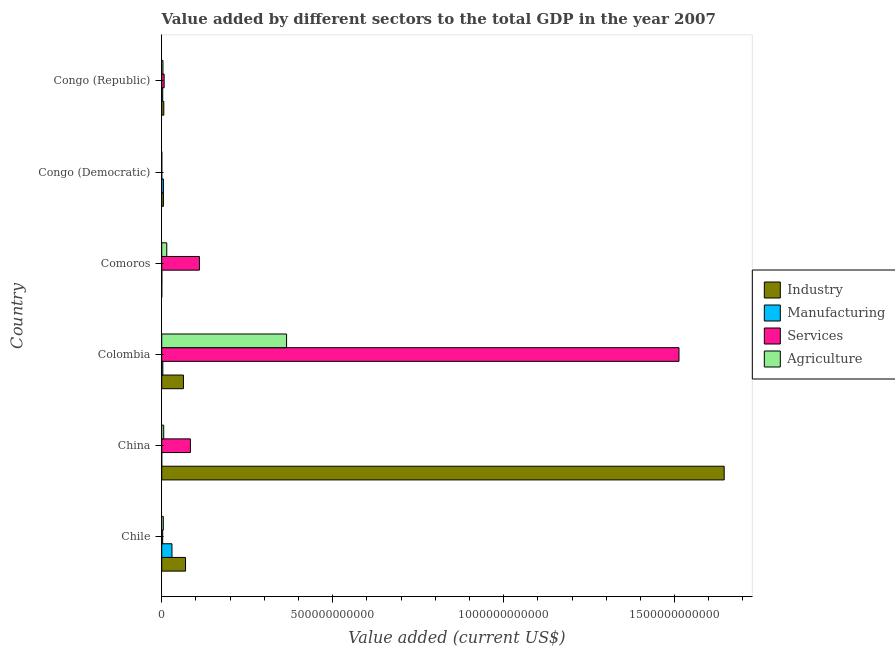Are the number of bars on each tick of the Y-axis equal?
Offer a very short reply. Yes. How many bars are there on the 6th tick from the top?
Offer a very short reply. 4. What is the label of the 4th group of bars from the top?
Your answer should be very brief. Colombia. In how many cases, is the number of bars for a given country not equal to the number of legend labels?
Offer a terse response. 0. What is the value added by services sector in Congo (Republic)?
Make the answer very short. 7.15e+09. Across all countries, what is the maximum value added by services sector?
Your answer should be compact. 1.51e+12. Across all countries, what is the minimum value added by agricultural sector?
Your answer should be compact. 1.89e+08. In which country was the value added by services sector minimum?
Your answer should be very brief. Congo (Democratic). What is the total value added by manufacturing sector in the graph?
Your answer should be compact. 4.16e+1. What is the difference between the value added by agricultural sector in Colombia and that in Congo (Republic)?
Make the answer very short. 3.62e+11. What is the difference between the value added by agricultural sector in Congo (Republic) and the value added by manufacturing sector in Chile?
Give a very brief answer. -2.64e+1. What is the average value added by industrial sector per country?
Offer a very short reply. 2.98e+11. What is the difference between the value added by services sector and value added by agricultural sector in Chile?
Offer a very short reply. -1.85e+09. In how many countries, is the value added by industrial sector greater than 700000000000 US$?
Offer a terse response. 1. What is the ratio of the value added by industrial sector in Chile to that in Congo (Democratic)?
Your answer should be very brief. 13.78. Is the value added by manufacturing sector in Comoros less than that in Congo (Democratic)?
Make the answer very short. Yes. What is the difference between the highest and the second highest value added by industrial sector?
Offer a very short reply. 1.58e+12. What is the difference between the highest and the lowest value added by agricultural sector?
Make the answer very short. 3.65e+11. In how many countries, is the value added by manufacturing sector greater than the average value added by manufacturing sector taken over all countries?
Give a very brief answer. 1. Is it the case that in every country, the sum of the value added by manufacturing sector and value added by agricultural sector is greater than the sum of value added by industrial sector and value added by services sector?
Your response must be concise. No. What does the 4th bar from the top in Congo (Democratic) represents?
Your answer should be very brief. Industry. What does the 3rd bar from the bottom in China represents?
Provide a succinct answer. Services. How many countries are there in the graph?
Provide a succinct answer. 6. What is the difference between two consecutive major ticks on the X-axis?
Your response must be concise. 5.00e+11. Where does the legend appear in the graph?
Offer a terse response. Center right. How are the legend labels stacked?
Keep it short and to the point. Vertical. What is the title of the graph?
Provide a succinct answer. Value added by different sectors to the total GDP in the year 2007. What is the label or title of the X-axis?
Make the answer very short. Value added (current US$). What is the label or title of the Y-axis?
Offer a terse response. Country. What is the Value added (current US$) in Industry in Chile?
Make the answer very short. 6.97e+1. What is the Value added (current US$) in Manufacturing in Chile?
Ensure brevity in your answer.  3.00e+1. What is the Value added (current US$) of Services in Chile?
Keep it short and to the point. 2.87e+09. What is the Value added (current US$) of Agriculture in Chile?
Provide a short and direct response. 4.72e+09. What is the Value added (current US$) of Industry in China?
Provide a succinct answer. 1.65e+12. What is the Value added (current US$) of Manufacturing in China?
Offer a terse response. 1.89e+07. What is the Value added (current US$) in Services in China?
Give a very brief answer. 8.39e+1. What is the Value added (current US$) in Agriculture in China?
Provide a succinct answer. 5.89e+09. What is the Value added (current US$) in Industry in Colombia?
Your response must be concise. 6.35e+1. What is the Value added (current US$) in Manufacturing in Colombia?
Provide a short and direct response. 3.28e+09. What is the Value added (current US$) in Services in Colombia?
Keep it short and to the point. 1.51e+12. What is the Value added (current US$) of Agriculture in Colombia?
Provide a short and direct response. 3.65e+11. What is the Value added (current US$) in Industry in Comoros?
Make the answer very short. 5.03e+07. What is the Value added (current US$) in Manufacturing in Comoros?
Your answer should be compact. 3.38e+08. What is the Value added (current US$) of Services in Comoros?
Offer a terse response. 1.10e+11. What is the Value added (current US$) in Agriculture in Comoros?
Provide a succinct answer. 1.48e+1. What is the Value added (current US$) of Industry in Congo (Democratic)?
Ensure brevity in your answer.  5.06e+09. What is the Value added (current US$) of Manufacturing in Congo (Democratic)?
Your response must be concise. 5.03e+09. What is the Value added (current US$) of Services in Congo (Democratic)?
Your answer should be compact. 2.23e+08. What is the Value added (current US$) in Agriculture in Congo (Democratic)?
Your answer should be very brief. 1.89e+08. What is the Value added (current US$) of Industry in Congo (Republic)?
Offer a very short reply. 6.15e+09. What is the Value added (current US$) of Manufacturing in Congo (Republic)?
Offer a terse response. 2.96e+09. What is the Value added (current US$) in Services in Congo (Republic)?
Offer a very short reply. 7.15e+09. What is the Value added (current US$) of Agriculture in Congo (Republic)?
Provide a succinct answer. 3.62e+09. Across all countries, what is the maximum Value added (current US$) in Industry?
Provide a short and direct response. 1.65e+12. Across all countries, what is the maximum Value added (current US$) in Manufacturing?
Ensure brevity in your answer.  3.00e+1. Across all countries, what is the maximum Value added (current US$) in Services?
Offer a terse response. 1.51e+12. Across all countries, what is the maximum Value added (current US$) of Agriculture?
Your response must be concise. 3.65e+11. Across all countries, what is the minimum Value added (current US$) in Industry?
Your answer should be compact. 5.03e+07. Across all countries, what is the minimum Value added (current US$) in Manufacturing?
Your answer should be compact. 1.89e+07. Across all countries, what is the minimum Value added (current US$) of Services?
Offer a terse response. 2.23e+08. Across all countries, what is the minimum Value added (current US$) in Agriculture?
Give a very brief answer. 1.89e+08. What is the total Value added (current US$) in Industry in the graph?
Make the answer very short. 1.79e+12. What is the total Value added (current US$) of Manufacturing in the graph?
Your answer should be very brief. 4.16e+1. What is the total Value added (current US$) in Services in the graph?
Offer a very short reply. 1.72e+12. What is the total Value added (current US$) of Agriculture in the graph?
Make the answer very short. 3.94e+11. What is the difference between the Value added (current US$) in Industry in Chile and that in China?
Keep it short and to the point. -1.58e+12. What is the difference between the Value added (current US$) in Manufacturing in Chile and that in China?
Provide a succinct answer. 3.00e+1. What is the difference between the Value added (current US$) in Services in Chile and that in China?
Offer a terse response. -8.10e+1. What is the difference between the Value added (current US$) of Agriculture in Chile and that in China?
Your response must be concise. -1.16e+09. What is the difference between the Value added (current US$) of Industry in Chile and that in Colombia?
Offer a very short reply. 6.13e+09. What is the difference between the Value added (current US$) in Manufacturing in Chile and that in Colombia?
Offer a very short reply. 2.67e+1. What is the difference between the Value added (current US$) in Services in Chile and that in Colombia?
Give a very brief answer. -1.51e+12. What is the difference between the Value added (current US$) in Agriculture in Chile and that in Colombia?
Your response must be concise. -3.60e+11. What is the difference between the Value added (current US$) of Industry in Chile and that in Comoros?
Your response must be concise. 6.96e+1. What is the difference between the Value added (current US$) in Manufacturing in Chile and that in Comoros?
Provide a succinct answer. 2.96e+1. What is the difference between the Value added (current US$) of Services in Chile and that in Comoros?
Your response must be concise. -1.07e+11. What is the difference between the Value added (current US$) of Agriculture in Chile and that in Comoros?
Keep it short and to the point. -1.00e+1. What is the difference between the Value added (current US$) in Industry in Chile and that in Congo (Democratic)?
Your answer should be compact. 6.46e+1. What is the difference between the Value added (current US$) in Manufacturing in Chile and that in Congo (Democratic)?
Keep it short and to the point. 2.50e+1. What is the difference between the Value added (current US$) of Services in Chile and that in Congo (Democratic)?
Make the answer very short. 2.65e+09. What is the difference between the Value added (current US$) of Agriculture in Chile and that in Congo (Democratic)?
Your answer should be compact. 4.53e+09. What is the difference between the Value added (current US$) in Industry in Chile and that in Congo (Republic)?
Provide a short and direct response. 6.35e+1. What is the difference between the Value added (current US$) of Manufacturing in Chile and that in Congo (Republic)?
Your answer should be very brief. 2.70e+1. What is the difference between the Value added (current US$) of Services in Chile and that in Congo (Republic)?
Your answer should be very brief. -4.28e+09. What is the difference between the Value added (current US$) of Agriculture in Chile and that in Congo (Republic)?
Provide a short and direct response. 1.11e+09. What is the difference between the Value added (current US$) in Industry in China and that in Colombia?
Give a very brief answer. 1.58e+12. What is the difference between the Value added (current US$) of Manufacturing in China and that in Colombia?
Offer a very short reply. -3.26e+09. What is the difference between the Value added (current US$) of Services in China and that in Colombia?
Make the answer very short. -1.43e+12. What is the difference between the Value added (current US$) of Agriculture in China and that in Colombia?
Your answer should be compact. -3.59e+11. What is the difference between the Value added (current US$) of Industry in China and that in Comoros?
Offer a very short reply. 1.64e+12. What is the difference between the Value added (current US$) of Manufacturing in China and that in Comoros?
Your answer should be compact. -3.20e+08. What is the difference between the Value added (current US$) of Services in China and that in Comoros?
Provide a succinct answer. -2.64e+1. What is the difference between the Value added (current US$) in Agriculture in China and that in Comoros?
Provide a succinct answer. -8.88e+09. What is the difference between the Value added (current US$) of Industry in China and that in Congo (Democratic)?
Offer a terse response. 1.64e+12. What is the difference between the Value added (current US$) in Manufacturing in China and that in Congo (Democratic)?
Your answer should be very brief. -5.01e+09. What is the difference between the Value added (current US$) in Services in China and that in Congo (Democratic)?
Ensure brevity in your answer.  8.37e+1. What is the difference between the Value added (current US$) of Agriculture in China and that in Congo (Democratic)?
Provide a short and direct response. 5.70e+09. What is the difference between the Value added (current US$) in Industry in China and that in Congo (Republic)?
Make the answer very short. 1.64e+12. What is the difference between the Value added (current US$) in Manufacturing in China and that in Congo (Republic)?
Ensure brevity in your answer.  -2.94e+09. What is the difference between the Value added (current US$) of Services in China and that in Congo (Republic)?
Your response must be concise. 7.67e+1. What is the difference between the Value added (current US$) of Agriculture in China and that in Congo (Republic)?
Offer a very short reply. 2.27e+09. What is the difference between the Value added (current US$) of Industry in Colombia and that in Comoros?
Give a very brief answer. 6.35e+1. What is the difference between the Value added (current US$) in Manufacturing in Colombia and that in Comoros?
Your answer should be very brief. 2.94e+09. What is the difference between the Value added (current US$) of Services in Colombia and that in Comoros?
Give a very brief answer. 1.40e+12. What is the difference between the Value added (current US$) of Agriculture in Colombia and that in Comoros?
Give a very brief answer. 3.50e+11. What is the difference between the Value added (current US$) in Industry in Colombia and that in Congo (Democratic)?
Provide a short and direct response. 5.85e+1. What is the difference between the Value added (current US$) in Manufacturing in Colombia and that in Congo (Democratic)?
Offer a terse response. -1.75e+09. What is the difference between the Value added (current US$) in Services in Colombia and that in Congo (Democratic)?
Provide a succinct answer. 1.51e+12. What is the difference between the Value added (current US$) in Agriculture in Colombia and that in Congo (Democratic)?
Provide a short and direct response. 3.65e+11. What is the difference between the Value added (current US$) of Industry in Colombia and that in Congo (Republic)?
Your response must be concise. 5.74e+1. What is the difference between the Value added (current US$) in Manufacturing in Colombia and that in Congo (Republic)?
Your answer should be compact. 3.16e+08. What is the difference between the Value added (current US$) of Services in Colombia and that in Congo (Republic)?
Provide a succinct answer. 1.51e+12. What is the difference between the Value added (current US$) in Agriculture in Colombia and that in Congo (Republic)?
Give a very brief answer. 3.62e+11. What is the difference between the Value added (current US$) in Industry in Comoros and that in Congo (Democratic)?
Offer a very short reply. -5.01e+09. What is the difference between the Value added (current US$) of Manufacturing in Comoros and that in Congo (Democratic)?
Your answer should be very brief. -4.69e+09. What is the difference between the Value added (current US$) in Services in Comoros and that in Congo (Democratic)?
Provide a succinct answer. 1.10e+11. What is the difference between the Value added (current US$) in Agriculture in Comoros and that in Congo (Democratic)?
Make the answer very short. 1.46e+1. What is the difference between the Value added (current US$) of Industry in Comoros and that in Congo (Republic)?
Your response must be concise. -6.10e+09. What is the difference between the Value added (current US$) in Manufacturing in Comoros and that in Congo (Republic)?
Provide a succinct answer. -2.62e+09. What is the difference between the Value added (current US$) of Services in Comoros and that in Congo (Republic)?
Provide a short and direct response. 1.03e+11. What is the difference between the Value added (current US$) of Agriculture in Comoros and that in Congo (Republic)?
Provide a succinct answer. 1.11e+1. What is the difference between the Value added (current US$) of Industry in Congo (Democratic) and that in Congo (Republic)?
Provide a short and direct response. -1.09e+09. What is the difference between the Value added (current US$) in Manufacturing in Congo (Democratic) and that in Congo (Republic)?
Provide a short and direct response. 2.07e+09. What is the difference between the Value added (current US$) in Services in Congo (Democratic) and that in Congo (Republic)?
Your answer should be very brief. -6.93e+09. What is the difference between the Value added (current US$) of Agriculture in Congo (Democratic) and that in Congo (Republic)?
Provide a short and direct response. -3.43e+09. What is the difference between the Value added (current US$) in Industry in Chile and the Value added (current US$) in Manufacturing in China?
Your answer should be compact. 6.96e+1. What is the difference between the Value added (current US$) in Industry in Chile and the Value added (current US$) in Services in China?
Ensure brevity in your answer.  -1.42e+1. What is the difference between the Value added (current US$) of Industry in Chile and the Value added (current US$) of Agriculture in China?
Keep it short and to the point. 6.38e+1. What is the difference between the Value added (current US$) of Manufacturing in Chile and the Value added (current US$) of Services in China?
Offer a very short reply. -5.39e+1. What is the difference between the Value added (current US$) in Manufacturing in Chile and the Value added (current US$) in Agriculture in China?
Ensure brevity in your answer.  2.41e+1. What is the difference between the Value added (current US$) of Services in Chile and the Value added (current US$) of Agriculture in China?
Make the answer very short. -3.02e+09. What is the difference between the Value added (current US$) in Industry in Chile and the Value added (current US$) in Manufacturing in Colombia?
Keep it short and to the point. 6.64e+1. What is the difference between the Value added (current US$) of Industry in Chile and the Value added (current US$) of Services in Colombia?
Your response must be concise. -1.44e+12. What is the difference between the Value added (current US$) of Industry in Chile and the Value added (current US$) of Agriculture in Colombia?
Your response must be concise. -2.96e+11. What is the difference between the Value added (current US$) of Manufacturing in Chile and the Value added (current US$) of Services in Colombia?
Your answer should be very brief. -1.48e+12. What is the difference between the Value added (current US$) of Manufacturing in Chile and the Value added (current US$) of Agriculture in Colombia?
Give a very brief answer. -3.35e+11. What is the difference between the Value added (current US$) of Services in Chile and the Value added (current US$) of Agriculture in Colombia?
Make the answer very short. -3.62e+11. What is the difference between the Value added (current US$) in Industry in Chile and the Value added (current US$) in Manufacturing in Comoros?
Keep it short and to the point. 6.93e+1. What is the difference between the Value added (current US$) in Industry in Chile and the Value added (current US$) in Services in Comoros?
Ensure brevity in your answer.  -4.06e+1. What is the difference between the Value added (current US$) in Industry in Chile and the Value added (current US$) in Agriculture in Comoros?
Your answer should be very brief. 5.49e+1. What is the difference between the Value added (current US$) of Manufacturing in Chile and the Value added (current US$) of Services in Comoros?
Make the answer very short. -8.03e+1. What is the difference between the Value added (current US$) in Manufacturing in Chile and the Value added (current US$) in Agriculture in Comoros?
Your response must be concise. 1.52e+1. What is the difference between the Value added (current US$) of Services in Chile and the Value added (current US$) of Agriculture in Comoros?
Your response must be concise. -1.19e+1. What is the difference between the Value added (current US$) of Industry in Chile and the Value added (current US$) of Manufacturing in Congo (Democratic)?
Make the answer very short. 6.46e+1. What is the difference between the Value added (current US$) in Industry in Chile and the Value added (current US$) in Services in Congo (Democratic)?
Provide a succinct answer. 6.94e+1. What is the difference between the Value added (current US$) of Industry in Chile and the Value added (current US$) of Agriculture in Congo (Democratic)?
Your answer should be compact. 6.95e+1. What is the difference between the Value added (current US$) of Manufacturing in Chile and the Value added (current US$) of Services in Congo (Democratic)?
Ensure brevity in your answer.  2.98e+1. What is the difference between the Value added (current US$) in Manufacturing in Chile and the Value added (current US$) in Agriculture in Congo (Democratic)?
Keep it short and to the point. 2.98e+1. What is the difference between the Value added (current US$) in Services in Chile and the Value added (current US$) in Agriculture in Congo (Democratic)?
Give a very brief answer. 2.68e+09. What is the difference between the Value added (current US$) of Industry in Chile and the Value added (current US$) of Manufacturing in Congo (Republic)?
Provide a short and direct response. 6.67e+1. What is the difference between the Value added (current US$) of Industry in Chile and the Value added (current US$) of Services in Congo (Republic)?
Your answer should be very brief. 6.25e+1. What is the difference between the Value added (current US$) of Industry in Chile and the Value added (current US$) of Agriculture in Congo (Republic)?
Ensure brevity in your answer.  6.61e+1. What is the difference between the Value added (current US$) of Manufacturing in Chile and the Value added (current US$) of Services in Congo (Republic)?
Provide a succinct answer. 2.28e+1. What is the difference between the Value added (current US$) of Manufacturing in Chile and the Value added (current US$) of Agriculture in Congo (Republic)?
Your response must be concise. 2.64e+1. What is the difference between the Value added (current US$) in Services in Chile and the Value added (current US$) in Agriculture in Congo (Republic)?
Keep it short and to the point. -7.43e+08. What is the difference between the Value added (current US$) in Industry in China and the Value added (current US$) in Manufacturing in Colombia?
Provide a short and direct response. 1.64e+12. What is the difference between the Value added (current US$) in Industry in China and the Value added (current US$) in Services in Colombia?
Give a very brief answer. 1.32e+11. What is the difference between the Value added (current US$) of Industry in China and the Value added (current US$) of Agriculture in Colombia?
Your answer should be compact. 1.28e+12. What is the difference between the Value added (current US$) in Manufacturing in China and the Value added (current US$) in Services in Colombia?
Offer a very short reply. -1.51e+12. What is the difference between the Value added (current US$) in Manufacturing in China and the Value added (current US$) in Agriculture in Colombia?
Your answer should be very brief. -3.65e+11. What is the difference between the Value added (current US$) in Services in China and the Value added (current US$) in Agriculture in Colombia?
Your answer should be very brief. -2.81e+11. What is the difference between the Value added (current US$) of Industry in China and the Value added (current US$) of Manufacturing in Comoros?
Offer a very short reply. 1.64e+12. What is the difference between the Value added (current US$) of Industry in China and the Value added (current US$) of Services in Comoros?
Offer a terse response. 1.53e+12. What is the difference between the Value added (current US$) of Industry in China and the Value added (current US$) of Agriculture in Comoros?
Provide a succinct answer. 1.63e+12. What is the difference between the Value added (current US$) in Manufacturing in China and the Value added (current US$) in Services in Comoros?
Your answer should be compact. -1.10e+11. What is the difference between the Value added (current US$) in Manufacturing in China and the Value added (current US$) in Agriculture in Comoros?
Ensure brevity in your answer.  -1.47e+1. What is the difference between the Value added (current US$) in Services in China and the Value added (current US$) in Agriculture in Comoros?
Offer a terse response. 6.91e+1. What is the difference between the Value added (current US$) in Industry in China and the Value added (current US$) in Manufacturing in Congo (Democratic)?
Your answer should be compact. 1.64e+12. What is the difference between the Value added (current US$) in Industry in China and the Value added (current US$) in Services in Congo (Democratic)?
Your answer should be very brief. 1.64e+12. What is the difference between the Value added (current US$) of Industry in China and the Value added (current US$) of Agriculture in Congo (Democratic)?
Your answer should be very brief. 1.64e+12. What is the difference between the Value added (current US$) of Manufacturing in China and the Value added (current US$) of Services in Congo (Democratic)?
Ensure brevity in your answer.  -2.04e+08. What is the difference between the Value added (current US$) in Manufacturing in China and the Value added (current US$) in Agriculture in Congo (Democratic)?
Offer a very short reply. -1.70e+08. What is the difference between the Value added (current US$) of Services in China and the Value added (current US$) of Agriculture in Congo (Democratic)?
Ensure brevity in your answer.  8.37e+1. What is the difference between the Value added (current US$) in Industry in China and the Value added (current US$) in Manufacturing in Congo (Republic)?
Offer a very short reply. 1.64e+12. What is the difference between the Value added (current US$) in Industry in China and the Value added (current US$) in Services in Congo (Republic)?
Offer a very short reply. 1.64e+12. What is the difference between the Value added (current US$) of Industry in China and the Value added (current US$) of Agriculture in Congo (Republic)?
Your answer should be compact. 1.64e+12. What is the difference between the Value added (current US$) of Manufacturing in China and the Value added (current US$) of Services in Congo (Republic)?
Your response must be concise. -7.14e+09. What is the difference between the Value added (current US$) in Manufacturing in China and the Value added (current US$) in Agriculture in Congo (Republic)?
Your answer should be very brief. -3.60e+09. What is the difference between the Value added (current US$) in Services in China and the Value added (current US$) in Agriculture in Congo (Republic)?
Ensure brevity in your answer.  8.03e+1. What is the difference between the Value added (current US$) of Industry in Colombia and the Value added (current US$) of Manufacturing in Comoros?
Your answer should be compact. 6.32e+1. What is the difference between the Value added (current US$) in Industry in Colombia and the Value added (current US$) in Services in Comoros?
Your answer should be compact. -4.67e+1. What is the difference between the Value added (current US$) of Industry in Colombia and the Value added (current US$) of Agriculture in Comoros?
Keep it short and to the point. 4.88e+1. What is the difference between the Value added (current US$) in Manufacturing in Colombia and the Value added (current US$) in Services in Comoros?
Your response must be concise. -1.07e+11. What is the difference between the Value added (current US$) in Manufacturing in Colombia and the Value added (current US$) in Agriculture in Comoros?
Your answer should be compact. -1.15e+1. What is the difference between the Value added (current US$) in Services in Colombia and the Value added (current US$) in Agriculture in Comoros?
Your answer should be very brief. 1.50e+12. What is the difference between the Value added (current US$) in Industry in Colombia and the Value added (current US$) in Manufacturing in Congo (Democratic)?
Keep it short and to the point. 5.85e+1. What is the difference between the Value added (current US$) of Industry in Colombia and the Value added (current US$) of Services in Congo (Democratic)?
Your answer should be very brief. 6.33e+1. What is the difference between the Value added (current US$) of Industry in Colombia and the Value added (current US$) of Agriculture in Congo (Democratic)?
Your response must be concise. 6.33e+1. What is the difference between the Value added (current US$) in Manufacturing in Colombia and the Value added (current US$) in Services in Congo (Democratic)?
Provide a short and direct response. 3.05e+09. What is the difference between the Value added (current US$) in Manufacturing in Colombia and the Value added (current US$) in Agriculture in Congo (Democratic)?
Provide a succinct answer. 3.09e+09. What is the difference between the Value added (current US$) in Services in Colombia and the Value added (current US$) in Agriculture in Congo (Democratic)?
Your answer should be very brief. 1.51e+12. What is the difference between the Value added (current US$) in Industry in Colombia and the Value added (current US$) in Manufacturing in Congo (Republic)?
Provide a short and direct response. 6.06e+1. What is the difference between the Value added (current US$) of Industry in Colombia and the Value added (current US$) of Services in Congo (Republic)?
Provide a succinct answer. 5.64e+1. What is the difference between the Value added (current US$) in Industry in Colombia and the Value added (current US$) in Agriculture in Congo (Republic)?
Give a very brief answer. 5.99e+1. What is the difference between the Value added (current US$) of Manufacturing in Colombia and the Value added (current US$) of Services in Congo (Republic)?
Offer a terse response. -3.88e+09. What is the difference between the Value added (current US$) in Manufacturing in Colombia and the Value added (current US$) in Agriculture in Congo (Republic)?
Your response must be concise. -3.38e+08. What is the difference between the Value added (current US$) in Services in Colombia and the Value added (current US$) in Agriculture in Congo (Republic)?
Keep it short and to the point. 1.51e+12. What is the difference between the Value added (current US$) in Industry in Comoros and the Value added (current US$) in Manufacturing in Congo (Democratic)?
Your answer should be very brief. -4.98e+09. What is the difference between the Value added (current US$) in Industry in Comoros and the Value added (current US$) in Services in Congo (Democratic)?
Your answer should be very brief. -1.73e+08. What is the difference between the Value added (current US$) of Industry in Comoros and the Value added (current US$) of Agriculture in Congo (Democratic)?
Offer a very short reply. -1.38e+08. What is the difference between the Value added (current US$) in Manufacturing in Comoros and the Value added (current US$) in Services in Congo (Democratic)?
Your response must be concise. 1.15e+08. What is the difference between the Value added (current US$) of Manufacturing in Comoros and the Value added (current US$) of Agriculture in Congo (Democratic)?
Keep it short and to the point. 1.50e+08. What is the difference between the Value added (current US$) in Services in Comoros and the Value added (current US$) in Agriculture in Congo (Democratic)?
Your answer should be very brief. 1.10e+11. What is the difference between the Value added (current US$) of Industry in Comoros and the Value added (current US$) of Manufacturing in Congo (Republic)?
Keep it short and to the point. -2.91e+09. What is the difference between the Value added (current US$) of Industry in Comoros and the Value added (current US$) of Services in Congo (Republic)?
Provide a short and direct response. -7.10e+09. What is the difference between the Value added (current US$) of Industry in Comoros and the Value added (current US$) of Agriculture in Congo (Republic)?
Your answer should be very brief. -3.57e+09. What is the difference between the Value added (current US$) of Manufacturing in Comoros and the Value added (current US$) of Services in Congo (Republic)?
Your response must be concise. -6.82e+09. What is the difference between the Value added (current US$) in Manufacturing in Comoros and the Value added (current US$) in Agriculture in Congo (Republic)?
Your response must be concise. -3.28e+09. What is the difference between the Value added (current US$) in Services in Comoros and the Value added (current US$) in Agriculture in Congo (Republic)?
Your answer should be compact. 1.07e+11. What is the difference between the Value added (current US$) of Industry in Congo (Democratic) and the Value added (current US$) of Manufacturing in Congo (Republic)?
Keep it short and to the point. 2.09e+09. What is the difference between the Value added (current US$) of Industry in Congo (Democratic) and the Value added (current US$) of Services in Congo (Republic)?
Make the answer very short. -2.10e+09. What is the difference between the Value added (current US$) of Industry in Congo (Democratic) and the Value added (current US$) of Agriculture in Congo (Republic)?
Provide a short and direct response. 1.44e+09. What is the difference between the Value added (current US$) in Manufacturing in Congo (Democratic) and the Value added (current US$) in Services in Congo (Republic)?
Offer a very short reply. -2.13e+09. What is the difference between the Value added (current US$) in Manufacturing in Congo (Democratic) and the Value added (current US$) in Agriculture in Congo (Republic)?
Offer a very short reply. 1.41e+09. What is the difference between the Value added (current US$) in Services in Congo (Democratic) and the Value added (current US$) in Agriculture in Congo (Republic)?
Provide a short and direct response. -3.39e+09. What is the average Value added (current US$) in Industry per country?
Make the answer very short. 2.98e+11. What is the average Value added (current US$) of Manufacturing per country?
Offer a very short reply. 6.93e+09. What is the average Value added (current US$) in Services per country?
Provide a succinct answer. 2.86e+11. What is the average Value added (current US$) of Agriculture per country?
Ensure brevity in your answer.  6.57e+1. What is the difference between the Value added (current US$) in Industry and Value added (current US$) in Manufacturing in Chile?
Your answer should be very brief. 3.97e+1. What is the difference between the Value added (current US$) of Industry and Value added (current US$) of Services in Chile?
Provide a succinct answer. 6.68e+1. What is the difference between the Value added (current US$) of Industry and Value added (current US$) of Agriculture in Chile?
Offer a very short reply. 6.49e+1. What is the difference between the Value added (current US$) in Manufacturing and Value added (current US$) in Services in Chile?
Offer a very short reply. 2.71e+1. What is the difference between the Value added (current US$) of Manufacturing and Value added (current US$) of Agriculture in Chile?
Give a very brief answer. 2.53e+1. What is the difference between the Value added (current US$) in Services and Value added (current US$) in Agriculture in Chile?
Offer a terse response. -1.85e+09. What is the difference between the Value added (current US$) of Industry and Value added (current US$) of Manufacturing in China?
Your answer should be compact. 1.65e+12. What is the difference between the Value added (current US$) of Industry and Value added (current US$) of Services in China?
Provide a short and direct response. 1.56e+12. What is the difference between the Value added (current US$) of Industry and Value added (current US$) of Agriculture in China?
Your response must be concise. 1.64e+12. What is the difference between the Value added (current US$) of Manufacturing and Value added (current US$) of Services in China?
Your answer should be very brief. -8.39e+1. What is the difference between the Value added (current US$) of Manufacturing and Value added (current US$) of Agriculture in China?
Your answer should be very brief. -5.87e+09. What is the difference between the Value added (current US$) of Services and Value added (current US$) of Agriculture in China?
Your response must be concise. 7.80e+1. What is the difference between the Value added (current US$) in Industry and Value added (current US$) in Manufacturing in Colombia?
Ensure brevity in your answer.  6.03e+1. What is the difference between the Value added (current US$) of Industry and Value added (current US$) of Services in Colombia?
Your answer should be compact. -1.45e+12. What is the difference between the Value added (current US$) in Industry and Value added (current US$) in Agriculture in Colombia?
Your answer should be very brief. -3.02e+11. What is the difference between the Value added (current US$) of Manufacturing and Value added (current US$) of Services in Colombia?
Your answer should be compact. -1.51e+12. What is the difference between the Value added (current US$) of Manufacturing and Value added (current US$) of Agriculture in Colombia?
Offer a very short reply. -3.62e+11. What is the difference between the Value added (current US$) of Services and Value added (current US$) of Agriculture in Colombia?
Your response must be concise. 1.15e+12. What is the difference between the Value added (current US$) in Industry and Value added (current US$) in Manufacturing in Comoros?
Offer a terse response. -2.88e+08. What is the difference between the Value added (current US$) of Industry and Value added (current US$) of Services in Comoros?
Give a very brief answer. -1.10e+11. What is the difference between the Value added (current US$) of Industry and Value added (current US$) of Agriculture in Comoros?
Ensure brevity in your answer.  -1.47e+1. What is the difference between the Value added (current US$) in Manufacturing and Value added (current US$) in Services in Comoros?
Make the answer very short. -1.10e+11. What is the difference between the Value added (current US$) in Manufacturing and Value added (current US$) in Agriculture in Comoros?
Your answer should be very brief. -1.44e+1. What is the difference between the Value added (current US$) in Services and Value added (current US$) in Agriculture in Comoros?
Your answer should be compact. 9.55e+1. What is the difference between the Value added (current US$) of Industry and Value added (current US$) of Manufacturing in Congo (Democratic)?
Give a very brief answer. 2.77e+07. What is the difference between the Value added (current US$) of Industry and Value added (current US$) of Services in Congo (Democratic)?
Provide a succinct answer. 4.83e+09. What is the difference between the Value added (current US$) of Industry and Value added (current US$) of Agriculture in Congo (Democratic)?
Your answer should be very brief. 4.87e+09. What is the difference between the Value added (current US$) of Manufacturing and Value added (current US$) of Services in Congo (Democratic)?
Make the answer very short. 4.80e+09. What is the difference between the Value added (current US$) in Manufacturing and Value added (current US$) in Agriculture in Congo (Democratic)?
Offer a very short reply. 4.84e+09. What is the difference between the Value added (current US$) in Services and Value added (current US$) in Agriculture in Congo (Democratic)?
Make the answer very short. 3.45e+07. What is the difference between the Value added (current US$) of Industry and Value added (current US$) of Manufacturing in Congo (Republic)?
Give a very brief answer. 3.19e+09. What is the difference between the Value added (current US$) in Industry and Value added (current US$) in Services in Congo (Republic)?
Your answer should be very brief. -1.01e+09. What is the difference between the Value added (current US$) of Industry and Value added (current US$) of Agriculture in Congo (Republic)?
Make the answer very short. 2.53e+09. What is the difference between the Value added (current US$) in Manufacturing and Value added (current US$) in Services in Congo (Republic)?
Your answer should be compact. -4.19e+09. What is the difference between the Value added (current US$) in Manufacturing and Value added (current US$) in Agriculture in Congo (Republic)?
Your response must be concise. -6.54e+08. What is the difference between the Value added (current US$) in Services and Value added (current US$) in Agriculture in Congo (Republic)?
Your answer should be compact. 3.54e+09. What is the ratio of the Value added (current US$) in Industry in Chile to that in China?
Offer a very short reply. 0.04. What is the ratio of the Value added (current US$) in Manufacturing in Chile to that in China?
Give a very brief answer. 1589.7. What is the ratio of the Value added (current US$) in Services in Chile to that in China?
Your answer should be compact. 0.03. What is the ratio of the Value added (current US$) of Agriculture in Chile to that in China?
Offer a very short reply. 0.8. What is the ratio of the Value added (current US$) of Industry in Chile to that in Colombia?
Offer a terse response. 1.1. What is the ratio of the Value added (current US$) of Manufacturing in Chile to that in Colombia?
Make the answer very short. 9.15. What is the ratio of the Value added (current US$) of Services in Chile to that in Colombia?
Ensure brevity in your answer.  0. What is the ratio of the Value added (current US$) in Agriculture in Chile to that in Colombia?
Your response must be concise. 0.01. What is the ratio of the Value added (current US$) in Industry in Chile to that in Comoros?
Offer a terse response. 1383.95. What is the ratio of the Value added (current US$) in Manufacturing in Chile to that in Comoros?
Provide a short and direct response. 88.6. What is the ratio of the Value added (current US$) in Services in Chile to that in Comoros?
Make the answer very short. 0.03. What is the ratio of the Value added (current US$) in Agriculture in Chile to that in Comoros?
Provide a succinct answer. 0.32. What is the ratio of the Value added (current US$) of Industry in Chile to that in Congo (Democratic)?
Ensure brevity in your answer.  13.78. What is the ratio of the Value added (current US$) of Manufacturing in Chile to that in Congo (Democratic)?
Your answer should be very brief. 5.96. What is the ratio of the Value added (current US$) of Services in Chile to that in Congo (Democratic)?
Give a very brief answer. 12.86. What is the ratio of the Value added (current US$) of Agriculture in Chile to that in Congo (Democratic)?
Offer a very short reply. 25.01. What is the ratio of the Value added (current US$) in Industry in Chile to that in Congo (Republic)?
Your answer should be compact. 11.33. What is the ratio of the Value added (current US$) in Manufacturing in Chile to that in Congo (Republic)?
Provide a succinct answer. 10.12. What is the ratio of the Value added (current US$) of Services in Chile to that in Congo (Republic)?
Give a very brief answer. 0.4. What is the ratio of the Value added (current US$) of Agriculture in Chile to that in Congo (Republic)?
Offer a very short reply. 1.31. What is the ratio of the Value added (current US$) in Industry in China to that in Colombia?
Your response must be concise. 25.89. What is the ratio of the Value added (current US$) in Manufacturing in China to that in Colombia?
Give a very brief answer. 0.01. What is the ratio of the Value added (current US$) in Services in China to that in Colombia?
Keep it short and to the point. 0.06. What is the ratio of the Value added (current US$) in Agriculture in China to that in Colombia?
Offer a very short reply. 0.02. What is the ratio of the Value added (current US$) of Industry in China to that in Comoros?
Provide a succinct answer. 3.27e+04. What is the ratio of the Value added (current US$) in Manufacturing in China to that in Comoros?
Make the answer very short. 0.06. What is the ratio of the Value added (current US$) of Services in China to that in Comoros?
Your answer should be compact. 0.76. What is the ratio of the Value added (current US$) in Agriculture in China to that in Comoros?
Make the answer very short. 0.4. What is the ratio of the Value added (current US$) of Industry in China to that in Congo (Democratic)?
Your answer should be compact. 325.39. What is the ratio of the Value added (current US$) in Manufacturing in China to that in Congo (Democratic)?
Give a very brief answer. 0. What is the ratio of the Value added (current US$) in Services in China to that in Congo (Democratic)?
Your answer should be very brief. 375.69. What is the ratio of the Value added (current US$) in Agriculture in China to that in Congo (Democratic)?
Make the answer very short. 31.18. What is the ratio of the Value added (current US$) in Industry in China to that in Congo (Republic)?
Keep it short and to the point. 267.56. What is the ratio of the Value added (current US$) in Manufacturing in China to that in Congo (Republic)?
Provide a short and direct response. 0.01. What is the ratio of the Value added (current US$) of Services in China to that in Congo (Republic)?
Provide a succinct answer. 11.72. What is the ratio of the Value added (current US$) of Agriculture in China to that in Congo (Republic)?
Your answer should be compact. 1.63. What is the ratio of the Value added (current US$) of Industry in Colombia to that in Comoros?
Your response must be concise. 1262.12. What is the ratio of the Value added (current US$) in Manufacturing in Colombia to that in Comoros?
Ensure brevity in your answer.  9.69. What is the ratio of the Value added (current US$) of Services in Colombia to that in Comoros?
Ensure brevity in your answer.  13.72. What is the ratio of the Value added (current US$) of Agriculture in Colombia to that in Comoros?
Offer a very short reply. 24.73. What is the ratio of the Value added (current US$) in Industry in Colombia to that in Congo (Democratic)?
Your response must be concise. 12.57. What is the ratio of the Value added (current US$) of Manufacturing in Colombia to that in Congo (Democratic)?
Your response must be concise. 0.65. What is the ratio of the Value added (current US$) in Services in Colombia to that in Congo (Democratic)?
Offer a very short reply. 6775.45. What is the ratio of the Value added (current US$) in Agriculture in Colombia to that in Congo (Democratic)?
Make the answer very short. 1934.07. What is the ratio of the Value added (current US$) in Industry in Colombia to that in Congo (Republic)?
Provide a succinct answer. 10.33. What is the ratio of the Value added (current US$) of Manufacturing in Colombia to that in Congo (Republic)?
Ensure brevity in your answer.  1.11. What is the ratio of the Value added (current US$) of Services in Colombia to that in Congo (Republic)?
Keep it short and to the point. 211.44. What is the ratio of the Value added (current US$) in Agriculture in Colombia to that in Congo (Republic)?
Your answer should be compact. 101.01. What is the ratio of the Value added (current US$) in Manufacturing in Comoros to that in Congo (Democratic)?
Make the answer very short. 0.07. What is the ratio of the Value added (current US$) of Services in Comoros to that in Congo (Democratic)?
Ensure brevity in your answer.  493.86. What is the ratio of the Value added (current US$) of Agriculture in Comoros to that in Congo (Democratic)?
Provide a short and direct response. 78.19. What is the ratio of the Value added (current US$) in Industry in Comoros to that in Congo (Republic)?
Ensure brevity in your answer.  0.01. What is the ratio of the Value added (current US$) in Manufacturing in Comoros to that in Congo (Republic)?
Provide a short and direct response. 0.11. What is the ratio of the Value added (current US$) of Services in Comoros to that in Congo (Republic)?
Give a very brief answer. 15.41. What is the ratio of the Value added (current US$) of Agriculture in Comoros to that in Congo (Republic)?
Offer a terse response. 4.08. What is the ratio of the Value added (current US$) in Industry in Congo (Democratic) to that in Congo (Republic)?
Your response must be concise. 0.82. What is the ratio of the Value added (current US$) of Manufacturing in Congo (Democratic) to that in Congo (Republic)?
Your answer should be compact. 1.7. What is the ratio of the Value added (current US$) in Services in Congo (Democratic) to that in Congo (Republic)?
Offer a terse response. 0.03. What is the ratio of the Value added (current US$) of Agriculture in Congo (Democratic) to that in Congo (Republic)?
Give a very brief answer. 0.05. What is the difference between the highest and the second highest Value added (current US$) of Industry?
Offer a very short reply. 1.58e+12. What is the difference between the highest and the second highest Value added (current US$) of Manufacturing?
Keep it short and to the point. 2.50e+1. What is the difference between the highest and the second highest Value added (current US$) of Services?
Keep it short and to the point. 1.40e+12. What is the difference between the highest and the second highest Value added (current US$) in Agriculture?
Make the answer very short. 3.50e+11. What is the difference between the highest and the lowest Value added (current US$) in Industry?
Provide a short and direct response. 1.64e+12. What is the difference between the highest and the lowest Value added (current US$) of Manufacturing?
Offer a very short reply. 3.00e+1. What is the difference between the highest and the lowest Value added (current US$) of Services?
Offer a terse response. 1.51e+12. What is the difference between the highest and the lowest Value added (current US$) of Agriculture?
Your response must be concise. 3.65e+11. 